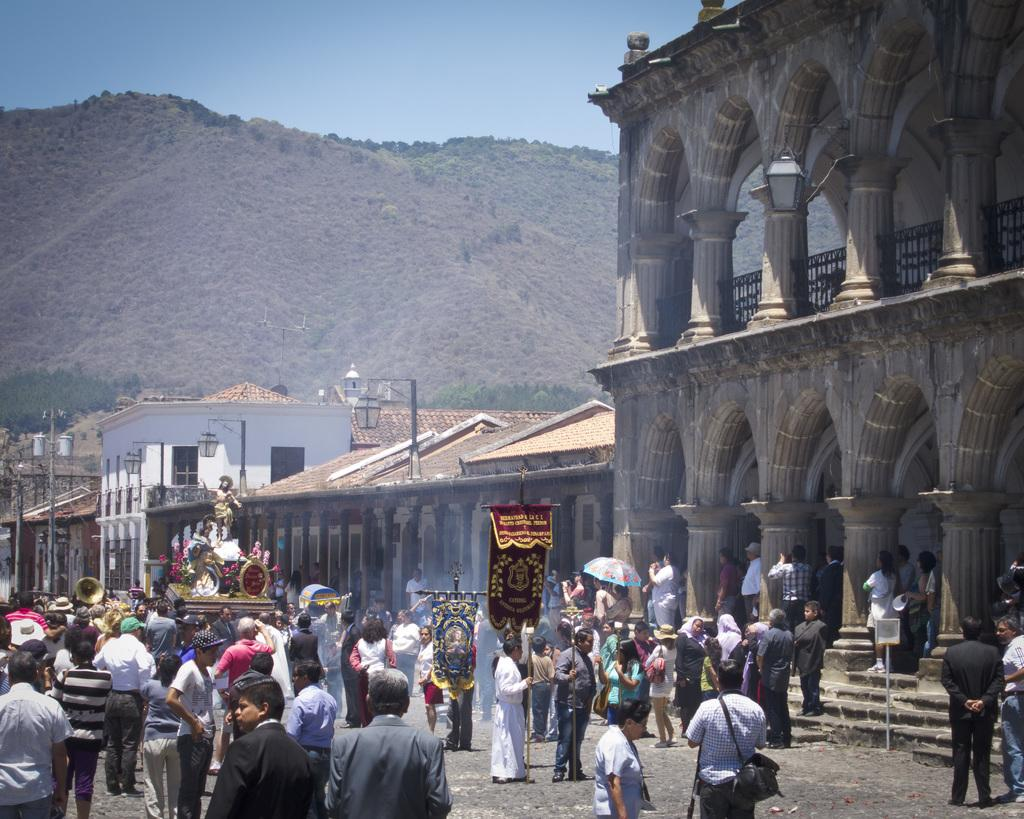Who or what can be seen in the image? There are people in the image. What architectural feature is present in the image? There are stairs in the image. What type of structures are visible in the image? There are buildings in the image. What other object can be seen in the image? There is a statue in the image. What type of lighting is present in the image? There are street lamps in the image. What type of natural feature is visible in the image? There are hills in the image. What part of the natural environment is visible in the image? The sky is visible in the image. Can you tell me how many potatoes are being cut by the knife in the image? There is no knife or potatoes present in the image. What type of squirrel can be seen climbing the statue in the image? There is no squirrel present in the image; only people, stairs, buildings, a statue, street lamps, hills, and the sky are visible. 